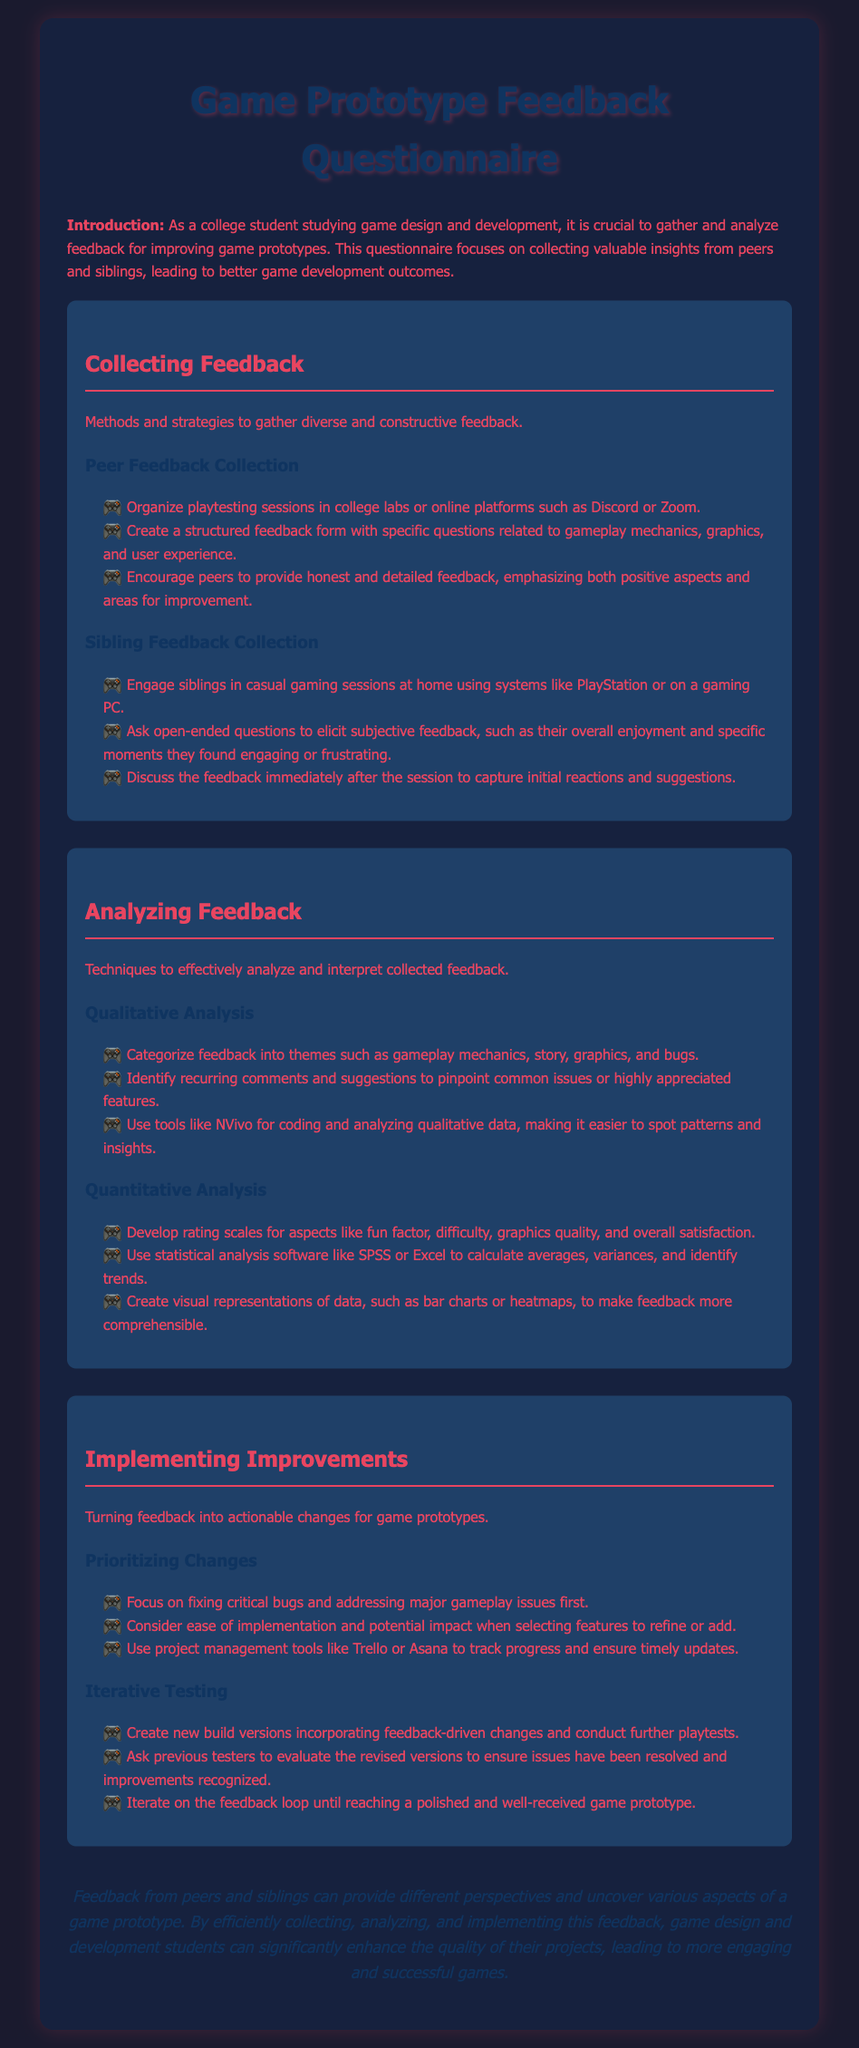what is the title of the questionnaire? The title of the questionnaire is mentioned at the top of the document.
Answer: Game Prototype Feedback Questionnaire who are the primary respondents targeted for feedback collection? The introduction mentions the groups from which feedback is gathered for game prototypes.
Answer: Peers and siblings what is one method for collecting feedback from siblings? The document lists various methods for sibling feedback collection, including engaging them in specific activities.
Answer: Casual gaming sessions name one tool mentioned for analyzing qualitative feedback. The qualitative analysis section refers to specific tools for coding and analyzing feedback data.
Answer: NVivo how should critical bugs be handled according to the document? The document indicates a priority system for addressing issues with game prototypes.
Answer: Fixed first what type of analysis uses rating scales? The quantitative analysis section describes the use of rating scales for specific aspects of gameplay.
Answer: Quantitative Analysis what is encouraged during peer feedback collection? The document specifies an approach that should be taken during peer feedback collection sessions for better insights.
Answer: Honest and detailed feedback how often should feedback loops occur when refining game prototypes? The iterative testing section describes the nature of feedback loops in relation to prototype improvements.
Answer: Until reaching a polished game prototype 